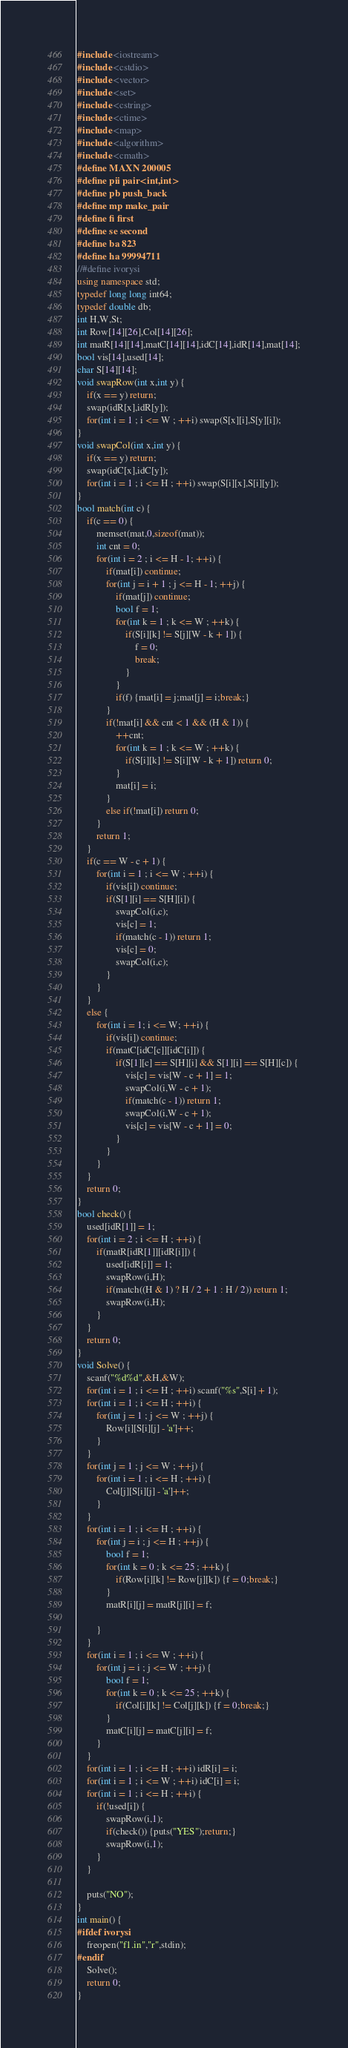<code> <loc_0><loc_0><loc_500><loc_500><_C++_>#include <iostream>
#include <cstdio>
#include <vector>
#include <set>
#include <cstring>
#include <ctime>
#include <map>
#include <algorithm>
#include <cmath>
#define MAXN 200005
#define pii pair<int,int>
#define pb push_back
#define mp make_pair
#define fi first
#define se second
#define ba 823
#define ha 99994711
//#define ivorysi
using namespace std;
typedef long long int64;
typedef double db;
int H,W,St;
int Row[14][26],Col[14][26];
int matR[14][14],matC[14][14],idC[14],idR[14],mat[14];
bool vis[14],used[14];
char S[14][14];
void swapRow(int x,int y) {
	if(x == y) return;
	swap(idR[x],idR[y]);
	for(int i = 1 ; i <= W ; ++i) swap(S[x][i],S[y][i]);
}
void swapCol(int x,int y) {
	if(x == y) return;
	swap(idC[x],idC[y]);
	for(int i = 1 ; i <= H ; ++i) swap(S[i][x],S[i][y]);
}
bool match(int c) {
	if(c == 0) {
		memset(mat,0,sizeof(mat));
		int cnt = 0;
		for(int i = 2 ; i <= H - 1; ++i) {
			if(mat[i]) continue;
			for(int j = i + 1 ; j <= H - 1; ++j) {
				if(mat[j]) continue;
				bool f = 1;
				for(int k = 1 ; k <= W ; ++k) {
					if(S[i][k] != S[j][W - k + 1]) {
						f = 0;
						break;
					}
				}
				if(f) {mat[i] = j;mat[j] = i;break;}
			}
			if(!mat[i] && cnt < 1 && (H & 1)) {
				++cnt;
				for(int k = 1 ; k <= W ; ++k) {
					if(S[i][k] != S[i][W - k + 1]) return 0;
				}
				mat[i] = i;
			}
			else if(!mat[i]) return 0;
		}
		return 1;
	}
	if(c == W - c + 1) {
		for(int i = 1 ; i <= W ; ++i) {
			if(vis[i]) continue;
			if(S[1][i] == S[H][i]) {
				swapCol(i,c);
				vis[c] = 1;
				if(match(c - 1)) return 1;
				vis[c] = 0;
				swapCol(i,c);
			}
		}
	}
	else {
		for(int i = 1; i <= W; ++i) {
			if(vis[i]) continue;
			if(matC[idC[c]][idC[i]]) {
				if(S[1][c] == S[H][i] && S[1][i] == S[H][c]) {
					vis[c] = vis[W - c + 1] = 1;
					swapCol(i,W - c + 1);
					if(match(c - 1)) return 1;
					swapCol(i,W - c + 1);
					vis[c] = vis[W - c + 1] = 0;
				}
			}
		}
	}
	return 0;
}
bool check() {
	used[idR[1]] = 1;
	for(int i = 2 ; i <= H ; ++i) {
		if(matR[idR[1]][idR[i]]) {
			used[idR[i]] = 1;
			swapRow(i,H);
			if(match((H & 1) ? H / 2 + 1 : H / 2)) return 1;
			swapRow(i,H);
		}
	}
	return 0;
}
void Solve() {
	scanf("%d%d",&H,&W);
	for(int i = 1 ; i <= H ; ++i) scanf("%s",S[i] + 1);
	for(int i = 1 ; i <= H ; ++i) {
		for(int j = 1 ; j <= W ; ++j) {
			Row[i][S[i][j] - 'a']++;
		}
	}
	for(int j = 1 ; j <= W ; ++j) {
		for(int i = 1 ; i <= H ; ++i) {
			Col[j][S[i][j] - 'a']++;
		}
	}
	for(int i = 1 ; i <= H ; ++i) {
		for(int j = i ; j <= H ; ++j) {
			bool f = 1;
			for(int k = 0 ; k <= 25 ; ++k) {
				if(Row[i][k] != Row[j][k]) {f = 0;break;}
			}
			matR[i][j] = matR[j][i] = f;
			
		}
	}
	for(int i = 1 ; i <= W ; ++i) {
		for(int j = i ; j <= W ; ++j) {
			bool f = 1;
			for(int k = 0 ; k <= 25 ; ++k) {
				if(Col[i][k] != Col[j][k]) {f = 0;break;}
			}
			matC[i][j] = matC[j][i] = f;
		}
	}
	for(int i = 1 ; i <= H ; ++i) idR[i] = i;
	for(int i = 1 ; i <= W ; ++i) idC[i] = i;
	for(int i = 1 ; i <= H ; ++i) {
		if(!used[i]) {
			swapRow(i,1);
			if(check()) {puts("YES");return;}
			swapRow(i,1);
		}
	}
	
	puts("NO");
}
int main() {
#ifdef ivorysi
    freopen("f1.in","r",stdin);
#endif
    Solve();
    return 0;
}</code> 